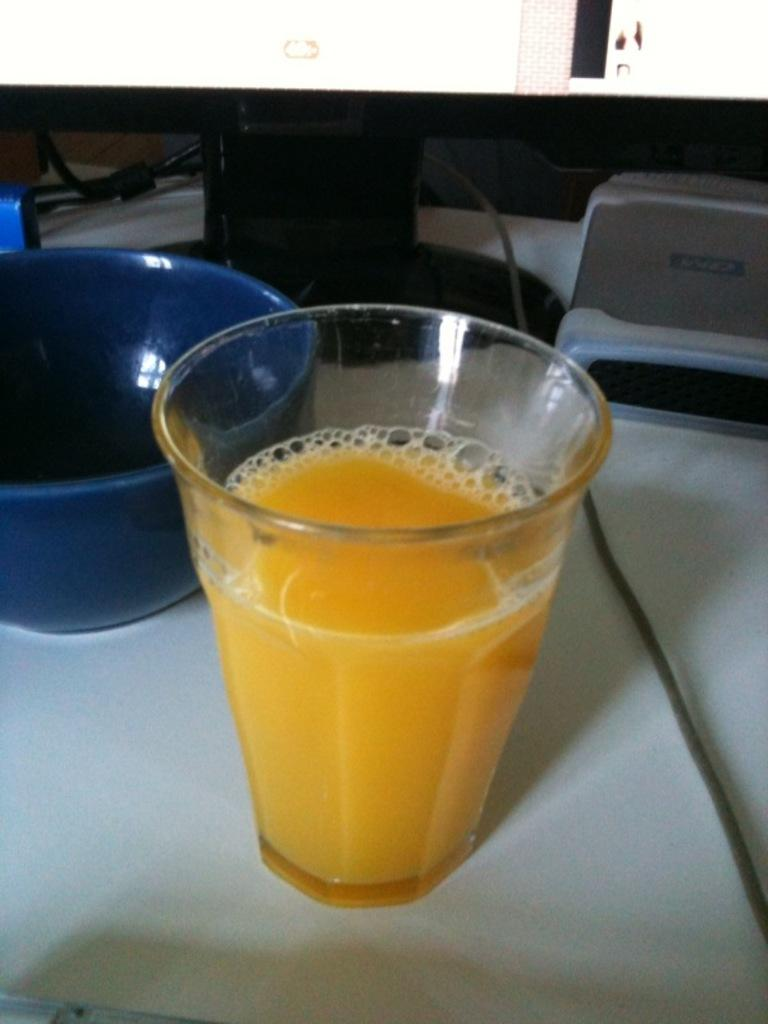What is located at the bottom of the image? There is a table at the bottom of the image. What objects can be seen on the table? There is a glass, a bowl, and a screen on the table. What else is visible in the image besides the table and its contents? There are wires visible in the image. What type of riddle is written on the screen in the image? There is no riddle written on the screen in the image; it is not mentioned in the provided facts. Can you see a sock on the table in the image? There is no sock present on the table in the image. 